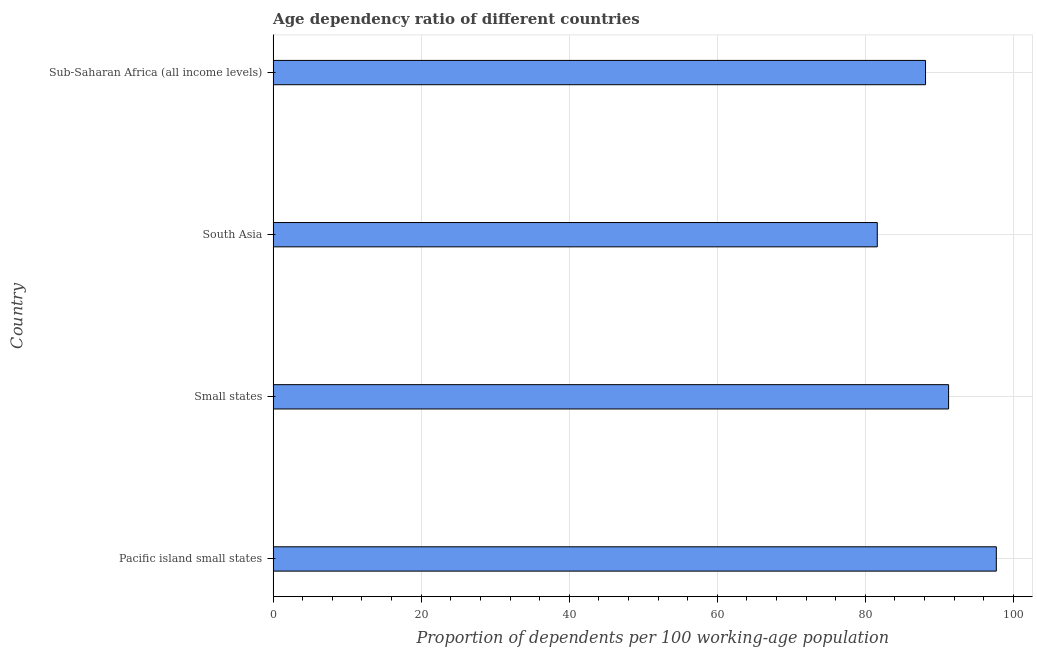Does the graph contain any zero values?
Make the answer very short. No. Does the graph contain grids?
Your answer should be very brief. Yes. What is the title of the graph?
Keep it short and to the point. Age dependency ratio of different countries. What is the label or title of the X-axis?
Give a very brief answer. Proportion of dependents per 100 working-age population. What is the label or title of the Y-axis?
Give a very brief answer. Country. What is the age dependency ratio in Small states?
Your answer should be compact. 91.25. Across all countries, what is the maximum age dependency ratio?
Provide a succinct answer. 97.69. Across all countries, what is the minimum age dependency ratio?
Ensure brevity in your answer.  81.61. In which country was the age dependency ratio maximum?
Make the answer very short. Pacific island small states. What is the sum of the age dependency ratio?
Offer a terse response. 358.68. What is the difference between the age dependency ratio in South Asia and Sub-Saharan Africa (all income levels)?
Your answer should be compact. -6.52. What is the average age dependency ratio per country?
Your answer should be very brief. 89.67. What is the median age dependency ratio?
Your response must be concise. 89.69. In how many countries, is the age dependency ratio greater than 96 ?
Ensure brevity in your answer.  1. What is the ratio of the age dependency ratio in Small states to that in South Asia?
Your answer should be compact. 1.12. Is the age dependency ratio in South Asia less than that in Sub-Saharan Africa (all income levels)?
Offer a very short reply. Yes. What is the difference between the highest and the second highest age dependency ratio?
Provide a short and direct response. 6.45. What is the difference between the highest and the lowest age dependency ratio?
Make the answer very short. 16.08. How many bars are there?
Offer a very short reply. 4. How many countries are there in the graph?
Ensure brevity in your answer.  4. What is the Proportion of dependents per 100 working-age population in Pacific island small states?
Offer a terse response. 97.69. What is the Proportion of dependents per 100 working-age population of Small states?
Keep it short and to the point. 91.25. What is the Proportion of dependents per 100 working-age population in South Asia?
Give a very brief answer. 81.61. What is the Proportion of dependents per 100 working-age population in Sub-Saharan Africa (all income levels)?
Give a very brief answer. 88.13. What is the difference between the Proportion of dependents per 100 working-age population in Pacific island small states and Small states?
Provide a short and direct response. 6.45. What is the difference between the Proportion of dependents per 100 working-age population in Pacific island small states and South Asia?
Ensure brevity in your answer.  16.08. What is the difference between the Proportion of dependents per 100 working-age population in Pacific island small states and Sub-Saharan Africa (all income levels)?
Your answer should be very brief. 9.56. What is the difference between the Proportion of dependents per 100 working-age population in Small states and South Asia?
Offer a very short reply. 9.63. What is the difference between the Proportion of dependents per 100 working-age population in Small states and Sub-Saharan Africa (all income levels)?
Offer a very short reply. 3.12. What is the difference between the Proportion of dependents per 100 working-age population in South Asia and Sub-Saharan Africa (all income levels)?
Give a very brief answer. -6.52. What is the ratio of the Proportion of dependents per 100 working-age population in Pacific island small states to that in Small states?
Keep it short and to the point. 1.07. What is the ratio of the Proportion of dependents per 100 working-age population in Pacific island small states to that in South Asia?
Your answer should be compact. 1.2. What is the ratio of the Proportion of dependents per 100 working-age population in Pacific island small states to that in Sub-Saharan Africa (all income levels)?
Your answer should be compact. 1.11. What is the ratio of the Proportion of dependents per 100 working-age population in Small states to that in South Asia?
Offer a very short reply. 1.12. What is the ratio of the Proportion of dependents per 100 working-age population in Small states to that in Sub-Saharan Africa (all income levels)?
Your answer should be compact. 1.03. What is the ratio of the Proportion of dependents per 100 working-age population in South Asia to that in Sub-Saharan Africa (all income levels)?
Your answer should be compact. 0.93. 